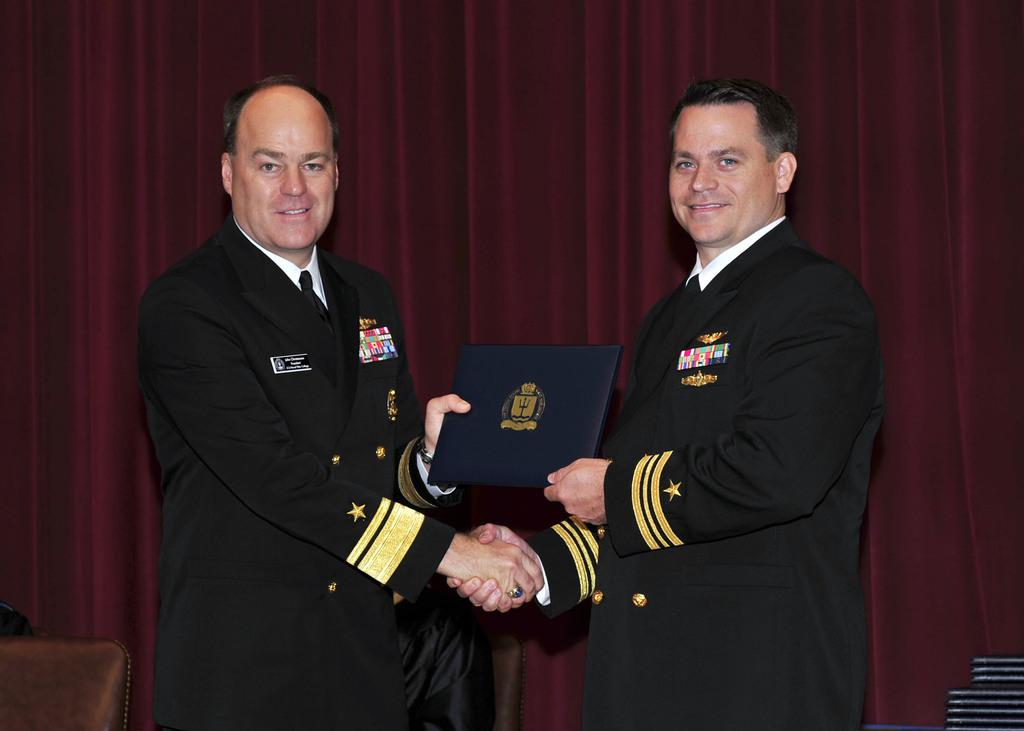How many people are in the image? There are two men in the image. What are the men wearing? The men are standing in uniforms. What are the men doing in the image? The men are holding each other's hands. What can be seen in the background of the image? There is a curtain in the background of the image. What type of credit card is visible in the image? There is no credit card present in the image. What color are the men's lips in the image? The provided facts do not mention the color of the men's lips, and therefore it cannot be determined from the image. 